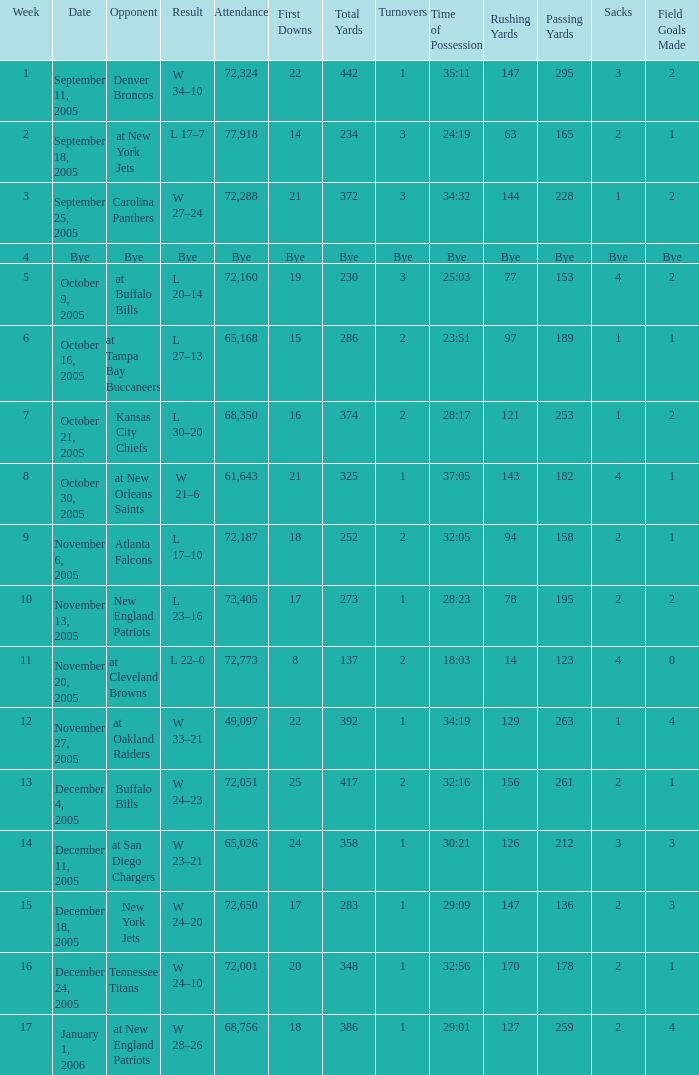What is the Date of the game with an attendance of 72,051 after Week 9? December 4, 2005. 